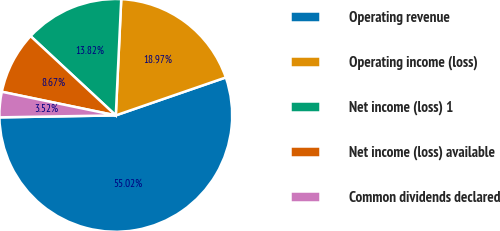Convert chart. <chart><loc_0><loc_0><loc_500><loc_500><pie_chart><fcel>Operating revenue<fcel>Operating income (loss)<fcel>Net income (loss) 1<fcel>Net income (loss) available<fcel>Common dividends declared<nl><fcel>55.01%<fcel>18.97%<fcel>13.82%<fcel>8.67%<fcel>3.52%<nl></chart> 